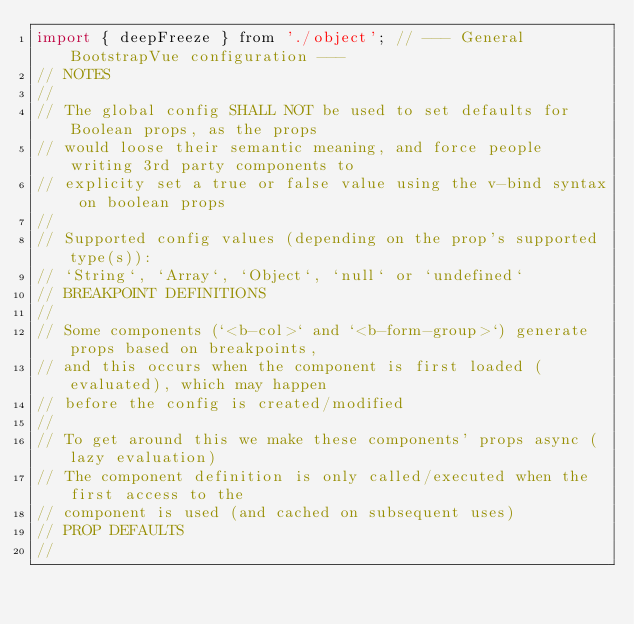Convert code to text. <code><loc_0><loc_0><loc_500><loc_500><_JavaScript_>import { deepFreeze } from './object'; // --- General BootstrapVue configuration ---
// NOTES
//
// The global config SHALL NOT be used to set defaults for Boolean props, as the props
// would loose their semantic meaning, and force people writing 3rd party components to
// explicity set a true or false value using the v-bind syntax on boolean props
//
// Supported config values (depending on the prop's supported type(s)):
// `String`, `Array`, `Object`, `null` or `undefined`
// BREAKPOINT DEFINITIONS
//
// Some components (`<b-col>` and `<b-form-group>`) generate props based on breakpoints,
// and this occurs when the component is first loaded (evaluated), which may happen
// before the config is created/modified
//
// To get around this we make these components' props async (lazy evaluation)
// The component definition is only called/executed when the first access to the
// component is used (and cached on subsequent uses)
// PROP DEFAULTS
//</code> 